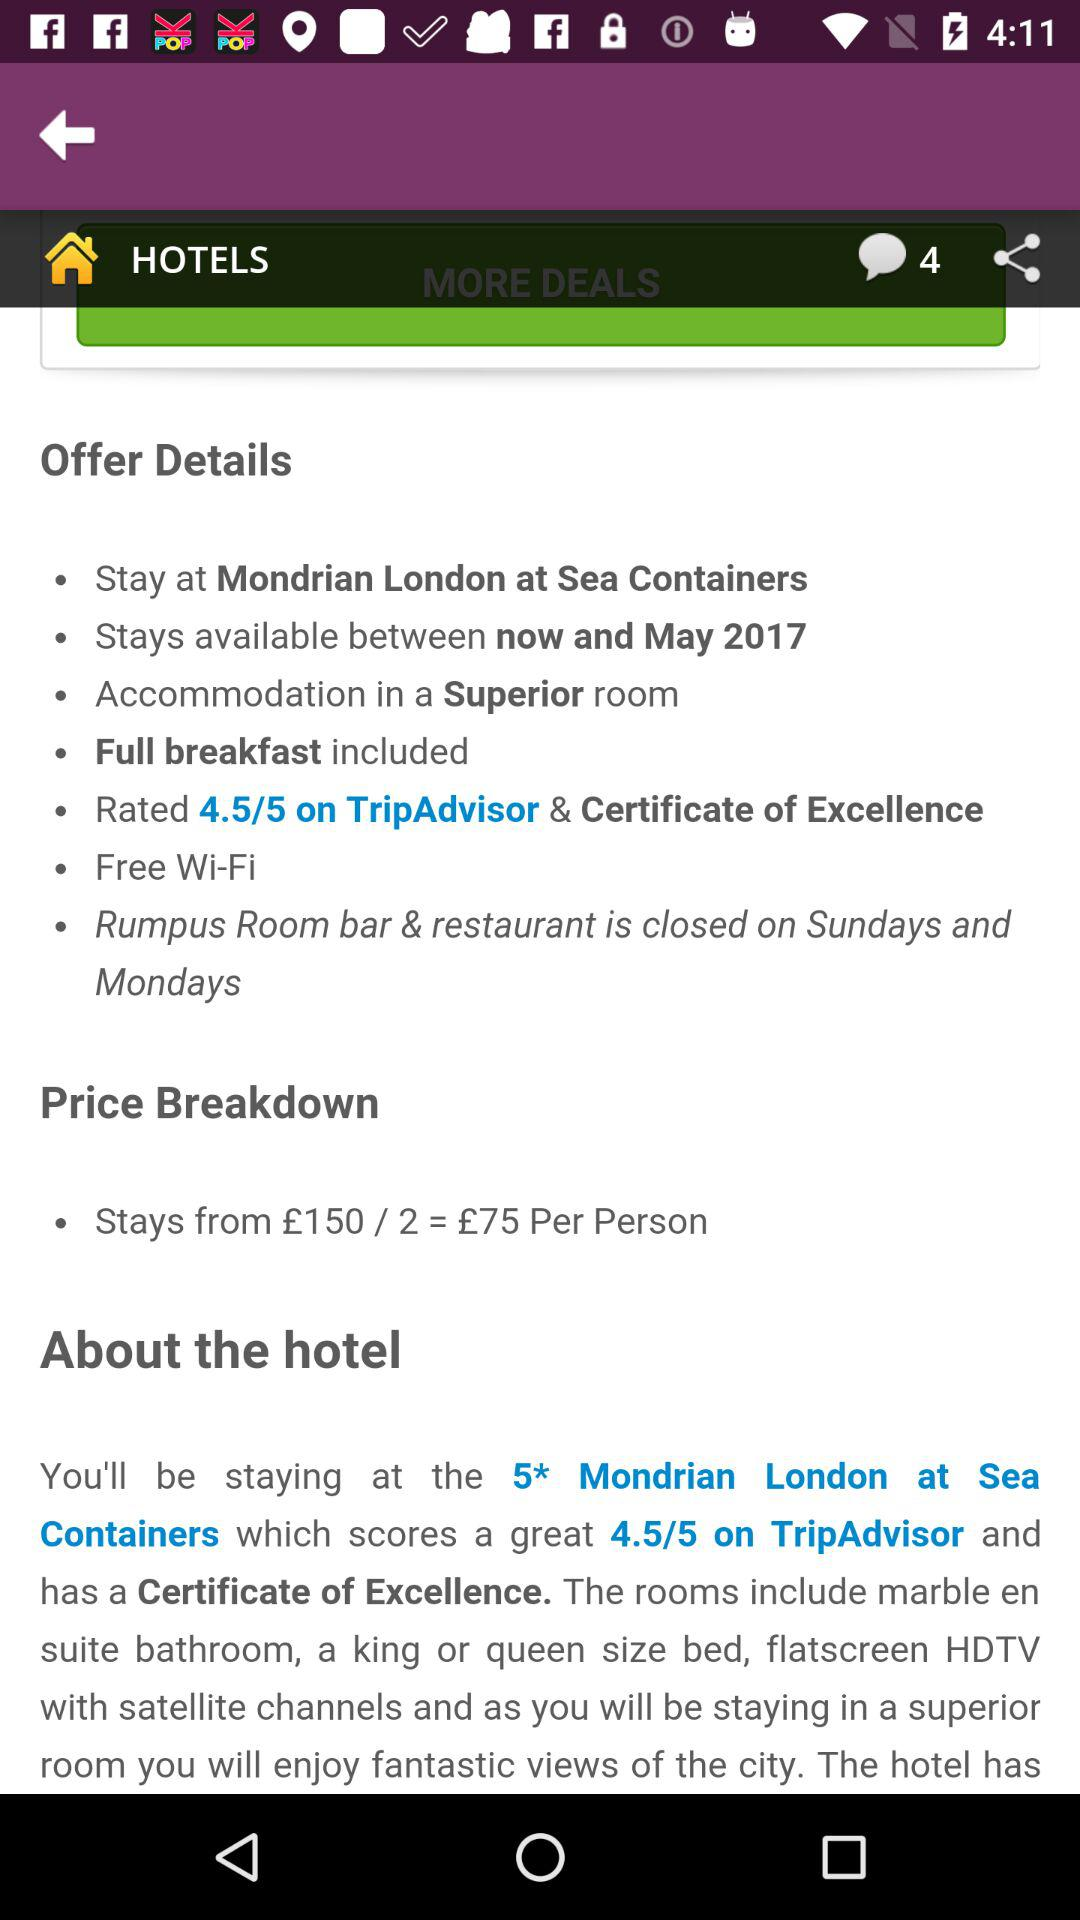What is the hotel offering? The hotel offers "Stay at Mondrian London at Sea Containers", "Stays available between now and May 2017", "Accommodation in a Superior room", "Full breakfast included", " Rated 4.5/5 on TripAdvisor & Certificate of Excellence" and "Free Wi-Fi". 